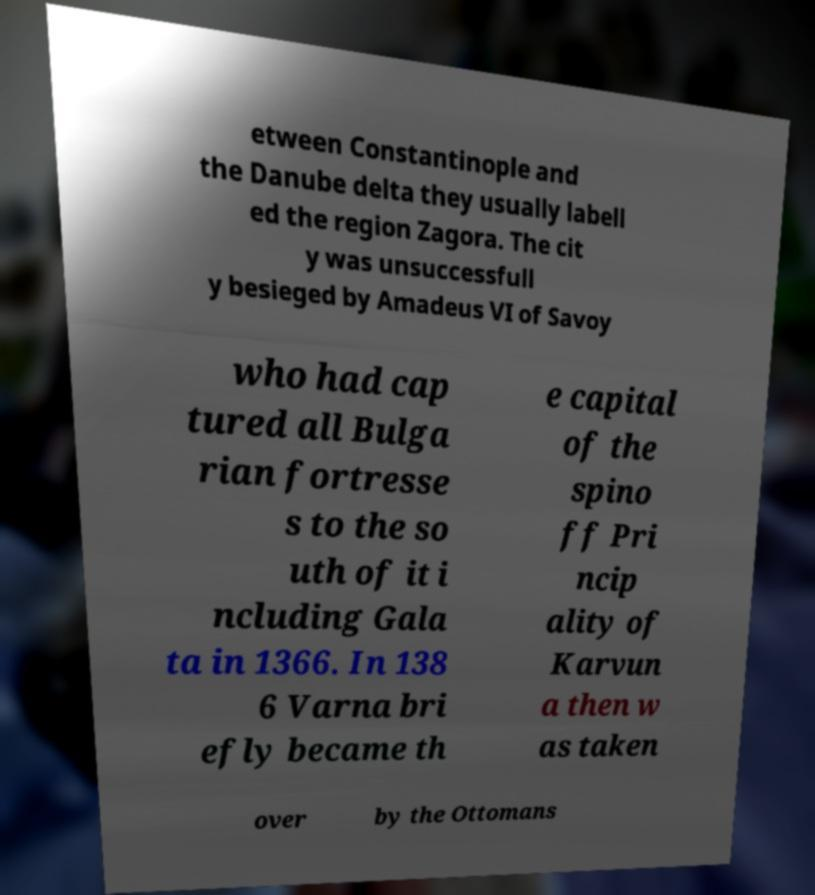Please identify and transcribe the text found in this image. etween Constantinople and the Danube delta they usually labell ed the region Zagora. The cit y was unsuccessfull y besieged by Amadeus VI of Savoy who had cap tured all Bulga rian fortresse s to the so uth of it i ncluding Gala ta in 1366. In 138 6 Varna bri efly became th e capital of the spino ff Pri ncip ality of Karvun a then w as taken over by the Ottomans 